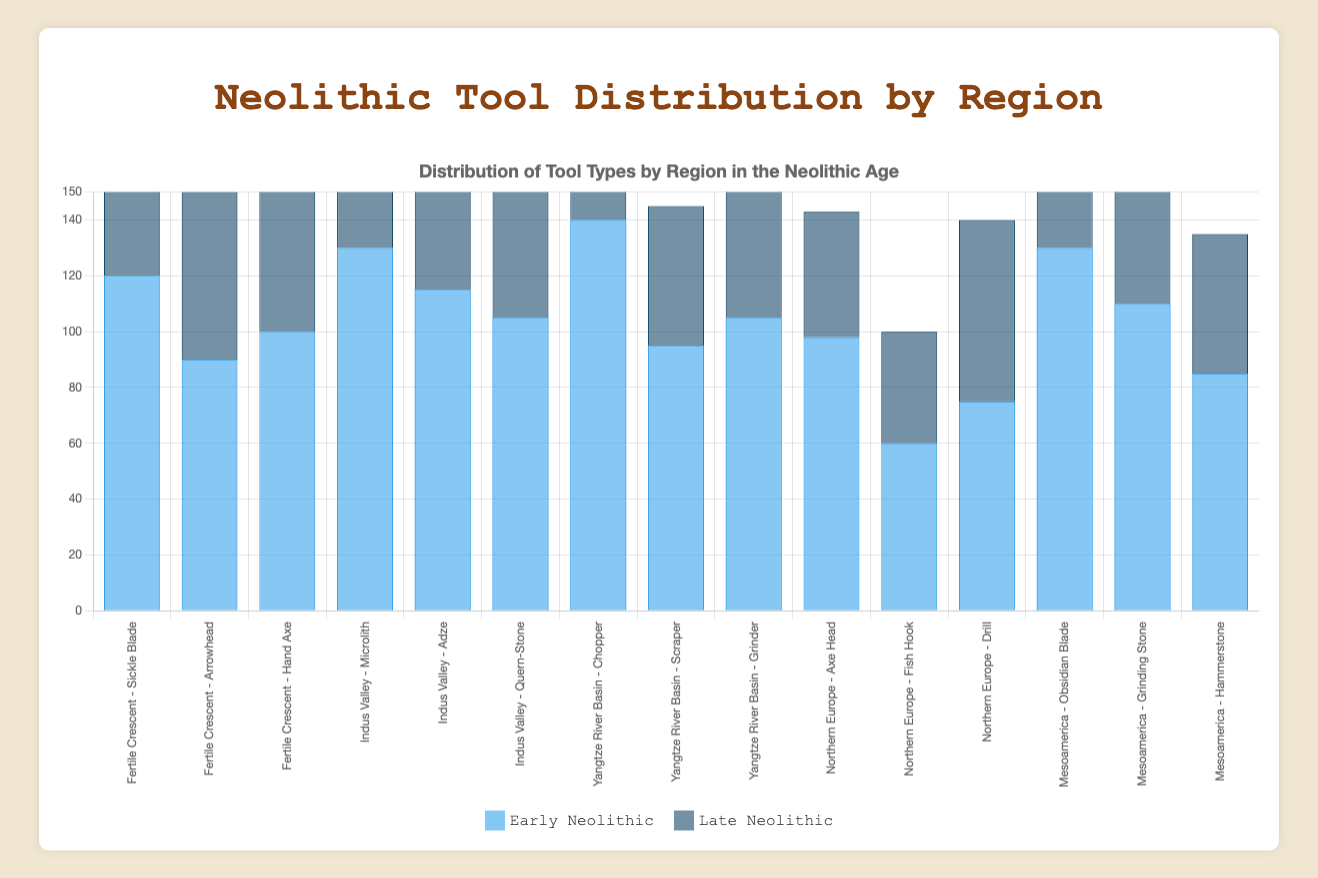Which region has the highest number of early Neolithic tool types? The Yangtze River Basin has the highest number of early Neolithic tool types, as all its tool types (Chopper, Scraper, Grinder) have higher counts in the early Neolithic period, with the Chopper having the highest count of 140.
Answer: Yangtze River Basin How does the count of sickle blades in the Fertile Crescent compare between the early and late Neolithic periods? The count of sickle blades in the early Neolithic period is 120, while in the late Neolithic period, it is 80. The early Neolithic count is higher than the late Neolithic count by 40.
Answer: 40 more in early Neolithic Which tool type in the Mesoamerica region shows the greatest difference between the early and late Neolithic periods? The Obsidian Blade in Mesoamerica shows the greatest difference between the early and late Neolithic periods, with a difference of 40 (130 in the early Neolithic period minus 90 in the late Neolithic period).
Answer: Obsidian Blade What is the average count of early Neolithic tools in Northern Europe? The counts of early Neolithic tools in Northern Europe are Axe Head (98), Fish Hook (60), and Drill (75). The total count is 98 + 60 + 75 = 233, and the average is 233 / 3 = 77.67.
Answer: 77.67 Which region has a tool type with the exact same count in both the early and the late Neolithic periods? Northern Europe has a tool type with the exact same count in both the early and the late Neolithic periods; the Drill has a count of 75 in both periods.
Answer: Northern Europe Compare the total counts of early Neolithic tools between the Yangtze River Basin and Mesoamerica. Which is higher? The total counts for early Neolithic tools are as follows: Yangtze River Basin (Chopper: 140, Scraper: 95, Grinder: 105), totaling 140 + 95 + 105 = 340. Mesoamerica (Obsidian Blade: 130, Grinding Stone: 110, Hammerstone: 85), totaling 130 + 110 + 85 = 325. The Yangtze River Basin has a higher total count.
Answer: Yangtze River Basin Which tool type in the Indus Valley has the highest count in the late Neolithic period? The Microlith has the highest count in the late Neolithic period in the Indus Valley, with a count of 70.
Answer: Microlith By how much does the count of hand axes in the Fertile Crescent differ between the early and late Neolithic periods? The count of hand axes in the early Neolithic period is 100, and in the late Neolithic period, it is 55. The difference is 100 - 55 = 45.
Answer: 45 What is the total number of grinder tools in the early Neolithic period across all regions? The total counts for grinder tools in the early Neolithic period are Yangtze River Basin (Grinder: 105) and Mesoamerica (Grinding Stone: 110), totaling 105 + 110 = 215.
Answer: 215 